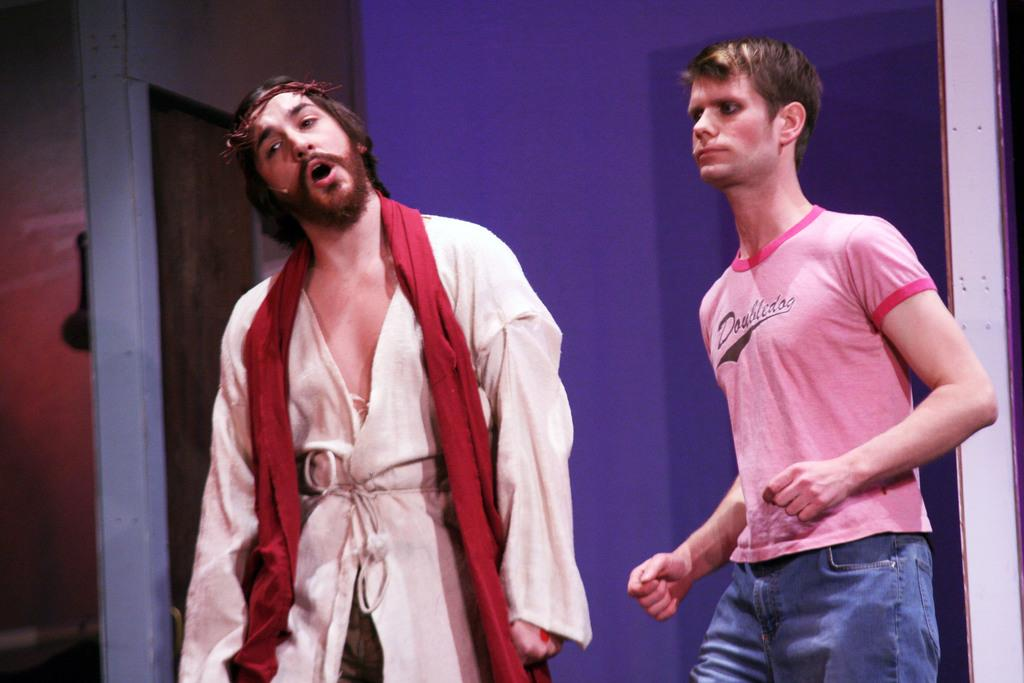How many people are in the image? There are two persons standing in the middle of the image. What are the two persons doing? The two persons are doing something, but we cannot determine the specific activity from the provided facts. What can be seen in the background of the image? There is a wall in the background of the image. What type of toad can be seen hopping on the grass in the image? There is no toad or grass present in the image; it features two persons standing in the middle of the image with a wall in the background. 